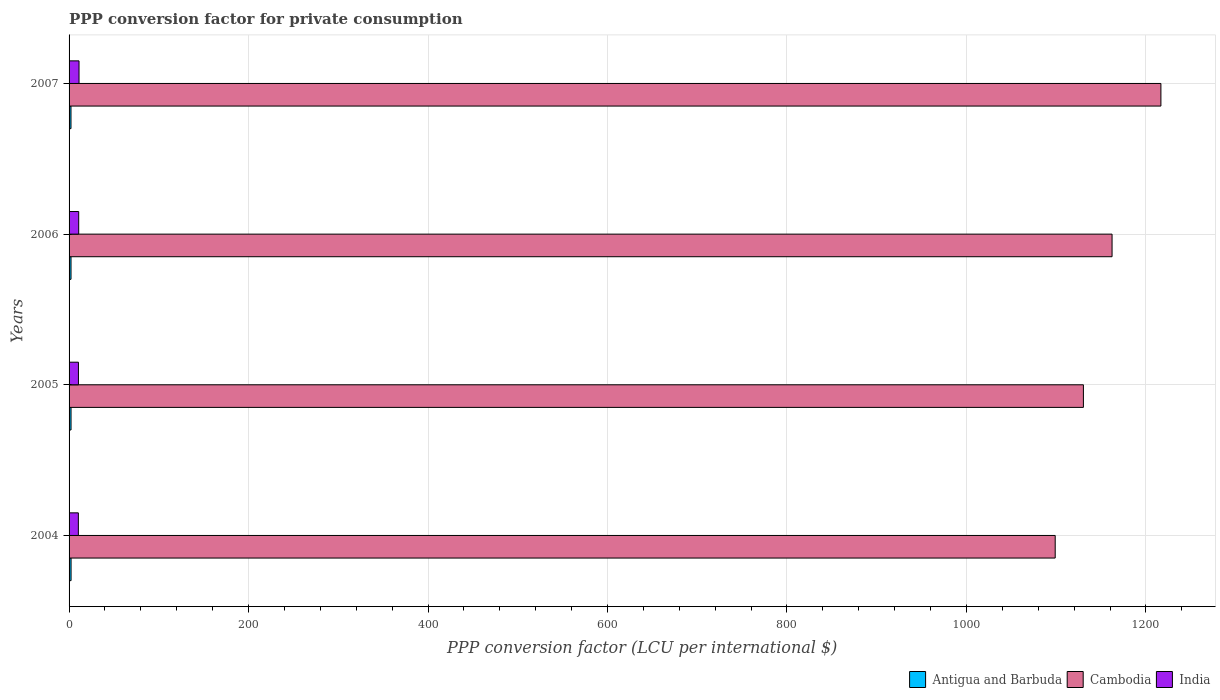How many groups of bars are there?
Give a very brief answer. 4. Are the number of bars on each tick of the Y-axis equal?
Provide a short and direct response. Yes. In how many cases, is the number of bars for a given year not equal to the number of legend labels?
Keep it short and to the point. 0. What is the PPP conversion factor for private consumption in Antigua and Barbuda in 2005?
Offer a very short reply. 2.19. Across all years, what is the maximum PPP conversion factor for private consumption in Antigua and Barbuda?
Offer a very short reply. 2.22. Across all years, what is the minimum PPP conversion factor for private consumption in Cambodia?
Provide a short and direct response. 1098.89. In which year was the PPP conversion factor for private consumption in Antigua and Barbuda maximum?
Offer a very short reply. 2004. What is the total PPP conversion factor for private consumption in India in the graph?
Make the answer very short. 42.59. What is the difference between the PPP conversion factor for private consumption in Antigua and Barbuda in 2006 and that in 2007?
Offer a very short reply. 0.03. What is the difference between the PPP conversion factor for private consumption in Antigua and Barbuda in 2004 and the PPP conversion factor for private consumption in India in 2005?
Ensure brevity in your answer.  -8.21. What is the average PPP conversion factor for private consumption in India per year?
Provide a short and direct response. 10.65. In the year 2005, what is the difference between the PPP conversion factor for private consumption in India and PPP conversion factor for private consumption in Antigua and Barbuda?
Provide a short and direct response. 8.24. What is the ratio of the PPP conversion factor for private consumption in Antigua and Barbuda in 2004 to that in 2007?
Your answer should be compact. 1.04. Is the difference between the PPP conversion factor for private consumption in India in 2004 and 2005 greater than the difference between the PPP conversion factor for private consumption in Antigua and Barbuda in 2004 and 2005?
Provide a succinct answer. No. What is the difference between the highest and the second highest PPP conversion factor for private consumption in Cambodia?
Offer a very short reply. 54.42. What is the difference between the highest and the lowest PPP conversion factor for private consumption in India?
Your answer should be compact. 0.75. Is the sum of the PPP conversion factor for private consumption in Cambodia in 2004 and 2005 greater than the maximum PPP conversion factor for private consumption in Antigua and Barbuda across all years?
Give a very brief answer. Yes. What does the 2nd bar from the top in 2007 represents?
Keep it short and to the point. Cambodia. Is it the case that in every year, the sum of the PPP conversion factor for private consumption in India and PPP conversion factor for private consumption in Antigua and Barbuda is greater than the PPP conversion factor for private consumption in Cambodia?
Ensure brevity in your answer.  No. How many years are there in the graph?
Ensure brevity in your answer.  4. What is the difference between two consecutive major ticks on the X-axis?
Keep it short and to the point. 200. Does the graph contain any zero values?
Provide a succinct answer. No. How are the legend labels stacked?
Provide a succinct answer. Horizontal. What is the title of the graph?
Give a very brief answer. PPP conversion factor for private consumption. What is the label or title of the X-axis?
Keep it short and to the point. PPP conversion factor (LCU per international $). What is the label or title of the Y-axis?
Offer a terse response. Years. What is the PPP conversion factor (LCU per international $) in Antigua and Barbuda in 2004?
Give a very brief answer. 2.22. What is the PPP conversion factor (LCU per international $) in Cambodia in 2004?
Make the answer very short. 1098.89. What is the PPP conversion factor (LCU per international $) of India in 2004?
Offer a very short reply. 10.35. What is the PPP conversion factor (LCU per international $) in Antigua and Barbuda in 2005?
Your response must be concise. 2.19. What is the PPP conversion factor (LCU per international $) in Cambodia in 2005?
Your answer should be very brief. 1130.31. What is the PPP conversion factor (LCU per international $) in India in 2005?
Provide a short and direct response. 10.43. What is the PPP conversion factor (LCU per international $) in Antigua and Barbuda in 2006?
Your response must be concise. 2.16. What is the PPP conversion factor (LCU per international $) of Cambodia in 2006?
Offer a very short reply. 1162.25. What is the PPP conversion factor (LCU per international $) in India in 2006?
Ensure brevity in your answer.  10.73. What is the PPP conversion factor (LCU per international $) of Antigua and Barbuda in 2007?
Ensure brevity in your answer.  2.13. What is the PPP conversion factor (LCU per international $) of Cambodia in 2007?
Your answer should be very brief. 1216.67. What is the PPP conversion factor (LCU per international $) of India in 2007?
Your answer should be compact. 11.09. Across all years, what is the maximum PPP conversion factor (LCU per international $) of Antigua and Barbuda?
Provide a succinct answer. 2.22. Across all years, what is the maximum PPP conversion factor (LCU per international $) in Cambodia?
Ensure brevity in your answer.  1216.67. Across all years, what is the maximum PPP conversion factor (LCU per international $) of India?
Offer a very short reply. 11.09. Across all years, what is the minimum PPP conversion factor (LCU per international $) in Antigua and Barbuda?
Give a very brief answer. 2.13. Across all years, what is the minimum PPP conversion factor (LCU per international $) in Cambodia?
Provide a succinct answer. 1098.89. Across all years, what is the minimum PPP conversion factor (LCU per international $) of India?
Ensure brevity in your answer.  10.35. What is the total PPP conversion factor (LCU per international $) in Antigua and Barbuda in the graph?
Ensure brevity in your answer.  8.7. What is the total PPP conversion factor (LCU per international $) of Cambodia in the graph?
Ensure brevity in your answer.  4608.13. What is the total PPP conversion factor (LCU per international $) of India in the graph?
Ensure brevity in your answer.  42.59. What is the difference between the PPP conversion factor (LCU per international $) of Antigua and Barbuda in 2004 and that in 2005?
Ensure brevity in your answer.  0.03. What is the difference between the PPP conversion factor (LCU per international $) in Cambodia in 2004 and that in 2005?
Give a very brief answer. -31.42. What is the difference between the PPP conversion factor (LCU per international $) in India in 2004 and that in 2005?
Make the answer very short. -0.09. What is the difference between the PPP conversion factor (LCU per international $) in Antigua and Barbuda in 2004 and that in 2006?
Make the answer very short. 0.06. What is the difference between the PPP conversion factor (LCU per international $) in Cambodia in 2004 and that in 2006?
Keep it short and to the point. -63.37. What is the difference between the PPP conversion factor (LCU per international $) of India in 2004 and that in 2006?
Provide a succinct answer. -0.38. What is the difference between the PPP conversion factor (LCU per international $) in Antigua and Barbuda in 2004 and that in 2007?
Give a very brief answer. 0.09. What is the difference between the PPP conversion factor (LCU per international $) in Cambodia in 2004 and that in 2007?
Offer a very short reply. -117.79. What is the difference between the PPP conversion factor (LCU per international $) of India in 2004 and that in 2007?
Provide a succinct answer. -0.75. What is the difference between the PPP conversion factor (LCU per international $) of Antigua and Barbuda in 2005 and that in 2006?
Offer a terse response. 0.03. What is the difference between the PPP conversion factor (LCU per international $) of Cambodia in 2005 and that in 2006?
Provide a succinct answer. -31.94. What is the difference between the PPP conversion factor (LCU per international $) in India in 2005 and that in 2006?
Make the answer very short. -0.29. What is the difference between the PPP conversion factor (LCU per international $) in Antigua and Barbuda in 2005 and that in 2007?
Give a very brief answer. 0.06. What is the difference between the PPP conversion factor (LCU per international $) of Cambodia in 2005 and that in 2007?
Make the answer very short. -86.36. What is the difference between the PPP conversion factor (LCU per international $) in India in 2005 and that in 2007?
Keep it short and to the point. -0.66. What is the difference between the PPP conversion factor (LCU per international $) of Antigua and Barbuda in 2006 and that in 2007?
Provide a succinct answer. 0.03. What is the difference between the PPP conversion factor (LCU per international $) in Cambodia in 2006 and that in 2007?
Offer a terse response. -54.42. What is the difference between the PPP conversion factor (LCU per international $) of India in 2006 and that in 2007?
Offer a very short reply. -0.37. What is the difference between the PPP conversion factor (LCU per international $) in Antigua and Barbuda in 2004 and the PPP conversion factor (LCU per international $) in Cambodia in 2005?
Keep it short and to the point. -1128.09. What is the difference between the PPP conversion factor (LCU per international $) of Antigua and Barbuda in 2004 and the PPP conversion factor (LCU per international $) of India in 2005?
Offer a terse response. -8.21. What is the difference between the PPP conversion factor (LCU per international $) in Cambodia in 2004 and the PPP conversion factor (LCU per international $) in India in 2005?
Your response must be concise. 1088.46. What is the difference between the PPP conversion factor (LCU per international $) in Antigua and Barbuda in 2004 and the PPP conversion factor (LCU per international $) in Cambodia in 2006?
Keep it short and to the point. -1160.04. What is the difference between the PPP conversion factor (LCU per international $) of Antigua and Barbuda in 2004 and the PPP conversion factor (LCU per international $) of India in 2006?
Give a very brief answer. -8.51. What is the difference between the PPP conversion factor (LCU per international $) of Cambodia in 2004 and the PPP conversion factor (LCU per international $) of India in 2006?
Your answer should be compact. 1088.16. What is the difference between the PPP conversion factor (LCU per international $) in Antigua and Barbuda in 2004 and the PPP conversion factor (LCU per international $) in Cambodia in 2007?
Your answer should be very brief. -1214.45. What is the difference between the PPP conversion factor (LCU per international $) in Antigua and Barbuda in 2004 and the PPP conversion factor (LCU per international $) in India in 2007?
Ensure brevity in your answer.  -8.87. What is the difference between the PPP conversion factor (LCU per international $) in Cambodia in 2004 and the PPP conversion factor (LCU per international $) in India in 2007?
Your answer should be compact. 1087.8. What is the difference between the PPP conversion factor (LCU per international $) of Antigua and Barbuda in 2005 and the PPP conversion factor (LCU per international $) of Cambodia in 2006?
Give a very brief answer. -1160.06. What is the difference between the PPP conversion factor (LCU per international $) in Antigua and Barbuda in 2005 and the PPP conversion factor (LCU per international $) in India in 2006?
Keep it short and to the point. -8.53. What is the difference between the PPP conversion factor (LCU per international $) of Cambodia in 2005 and the PPP conversion factor (LCU per international $) of India in 2006?
Provide a short and direct response. 1119.59. What is the difference between the PPP conversion factor (LCU per international $) of Antigua and Barbuda in 2005 and the PPP conversion factor (LCU per international $) of Cambodia in 2007?
Your answer should be very brief. -1214.48. What is the difference between the PPP conversion factor (LCU per international $) in Antigua and Barbuda in 2005 and the PPP conversion factor (LCU per international $) in India in 2007?
Keep it short and to the point. -8.9. What is the difference between the PPP conversion factor (LCU per international $) in Cambodia in 2005 and the PPP conversion factor (LCU per international $) in India in 2007?
Provide a short and direct response. 1119.22. What is the difference between the PPP conversion factor (LCU per international $) of Antigua and Barbuda in 2006 and the PPP conversion factor (LCU per international $) of Cambodia in 2007?
Your response must be concise. -1214.51. What is the difference between the PPP conversion factor (LCU per international $) in Antigua and Barbuda in 2006 and the PPP conversion factor (LCU per international $) in India in 2007?
Make the answer very short. -8.93. What is the difference between the PPP conversion factor (LCU per international $) in Cambodia in 2006 and the PPP conversion factor (LCU per international $) in India in 2007?
Keep it short and to the point. 1151.16. What is the average PPP conversion factor (LCU per international $) in Antigua and Barbuda per year?
Keep it short and to the point. 2.18. What is the average PPP conversion factor (LCU per international $) of Cambodia per year?
Offer a very short reply. 1152.03. What is the average PPP conversion factor (LCU per international $) of India per year?
Your answer should be compact. 10.65. In the year 2004, what is the difference between the PPP conversion factor (LCU per international $) in Antigua and Barbuda and PPP conversion factor (LCU per international $) in Cambodia?
Your answer should be very brief. -1096.67. In the year 2004, what is the difference between the PPP conversion factor (LCU per international $) in Antigua and Barbuda and PPP conversion factor (LCU per international $) in India?
Provide a succinct answer. -8.13. In the year 2004, what is the difference between the PPP conversion factor (LCU per international $) of Cambodia and PPP conversion factor (LCU per international $) of India?
Make the answer very short. 1088.54. In the year 2005, what is the difference between the PPP conversion factor (LCU per international $) in Antigua and Barbuda and PPP conversion factor (LCU per international $) in Cambodia?
Your answer should be compact. -1128.12. In the year 2005, what is the difference between the PPP conversion factor (LCU per international $) of Antigua and Barbuda and PPP conversion factor (LCU per international $) of India?
Offer a terse response. -8.24. In the year 2005, what is the difference between the PPP conversion factor (LCU per international $) of Cambodia and PPP conversion factor (LCU per international $) of India?
Offer a terse response. 1119.88. In the year 2006, what is the difference between the PPP conversion factor (LCU per international $) in Antigua and Barbuda and PPP conversion factor (LCU per international $) in Cambodia?
Make the answer very short. -1160.09. In the year 2006, what is the difference between the PPP conversion factor (LCU per international $) of Antigua and Barbuda and PPP conversion factor (LCU per international $) of India?
Provide a succinct answer. -8.56. In the year 2006, what is the difference between the PPP conversion factor (LCU per international $) of Cambodia and PPP conversion factor (LCU per international $) of India?
Give a very brief answer. 1151.53. In the year 2007, what is the difference between the PPP conversion factor (LCU per international $) of Antigua and Barbuda and PPP conversion factor (LCU per international $) of Cambodia?
Offer a terse response. -1214.54. In the year 2007, what is the difference between the PPP conversion factor (LCU per international $) in Antigua and Barbuda and PPP conversion factor (LCU per international $) in India?
Provide a succinct answer. -8.96. In the year 2007, what is the difference between the PPP conversion factor (LCU per international $) in Cambodia and PPP conversion factor (LCU per international $) in India?
Provide a succinct answer. 1205.58. What is the ratio of the PPP conversion factor (LCU per international $) in Antigua and Barbuda in 2004 to that in 2005?
Make the answer very short. 1.01. What is the ratio of the PPP conversion factor (LCU per international $) of Cambodia in 2004 to that in 2005?
Ensure brevity in your answer.  0.97. What is the ratio of the PPP conversion factor (LCU per international $) in Antigua and Barbuda in 2004 to that in 2006?
Ensure brevity in your answer.  1.03. What is the ratio of the PPP conversion factor (LCU per international $) of Cambodia in 2004 to that in 2006?
Make the answer very short. 0.95. What is the ratio of the PPP conversion factor (LCU per international $) in India in 2004 to that in 2006?
Your answer should be compact. 0.96. What is the ratio of the PPP conversion factor (LCU per international $) of Antigua and Barbuda in 2004 to that in 2007?
Provide a succinct answer. 1.04. What is the ratio of the PPP conversion factor (LCU per international $) in Cambodia in 2004 to that in 2007?
Provide a succinct answer. 0.9. What is the ratio of the PPP conversion factor (LCU per international $) in India in 2004 to that in 2007?
Give a very brief answer. 0.93. What is the ratio of the PPP conversion factor (LCU per international $) in Antigua and Barbuda in 2005 to that in 2006?
Your answer should be very brief. 1.01. What is the ratio of the PPP conversion factor (LCU per international $) in Cambodia in 2005 to that in 2006?
Your answer should be compact. 0.97. What is the ratio of the PPP conversion factor (LCU per international $) of India in 2005 to that in 2006?
Keep it short and to the point. 0.97. What is the ratio of the PPP conversion factor (LCU per international $) of Antigua and Barbuda in 2005 to that in 2007?
Offer a terse response. 1.03. What is the ratio of the PPP conversion factor (LCU per international $) in Cambodia in 2005 to that in 2007?
Provide a short and direct response. 0.93. What is the ratio of the PPP conversion factor (LCU per international $) of India in 2005 to that in 2007?
Make the answer very short. 0.94. What is the ratio of the PPP conversion factor (LCU per international $) in Antigua and Barbuda in 2006 to that in 2007?
Offer a terse response. 1.01. What is the ratio of the PPP conversion factor (LCU per international $) of Cambodia in 2006 to that in 2007?
Your answer should be compact. 0.96. What is the ratio of the PPP conversion factor (LCU per international $) of India in 2006 to that in 2007?
Provide a short and direct response. 0.97. What is the difference between the highest and the second highest PPP conversion factor (LCU per international $) in Antigua and Barbuda?
Your answer should be very brief. 0.03. What is the difference between the highest and the second highest PPP conversion factor (LCU per international $) of Cambodia?
Keep it short and to the point. 54.42. What is the difference between the highest and the second highest PPP conversion factor (LCU per international $) of India?
Offer a terse response. 0.37. What is the difference between the highest and the lowest PPP conversion factor (LCU per international $) in Antigua and Barbuda?
Your response must be concise. 0.09. What is the difference between the highest and the lowest PPP conversion factor (LCU per international $) of Cambodia?
Your answer should be compact. 117.79. What is the difference between the highest and the lowest PPP conversion factor (LCU per international $) of India?
Keep it short and to the point. 0.75. 